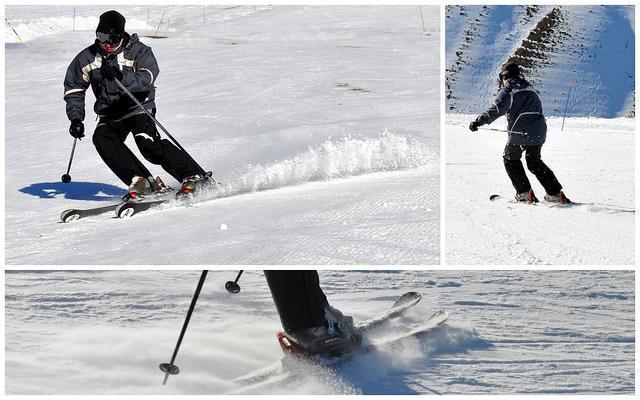How many people are there?
Give a very brief answer. 3. 